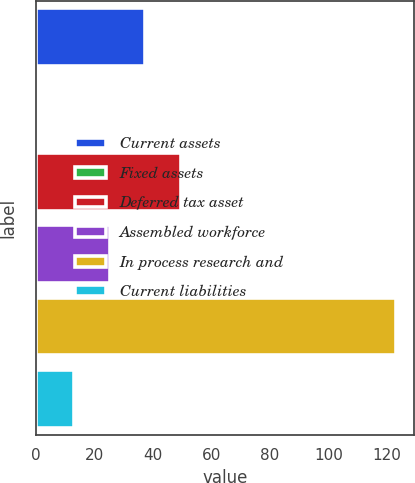<chart> <loc_0><loc_0><loc_500><loc_500><bar_chart><fcel>Current assets<fcel>Fixed assets<fcel>Deferred tax asset<fcel>Assembled workforce<fcel>In process research and<fcel>Current liabilities<nl><fcel>37.49<fcel>0.8<fcel>49.72<fcel>25.26<fcel>123.1<fcel>13.03<nl></chart> 